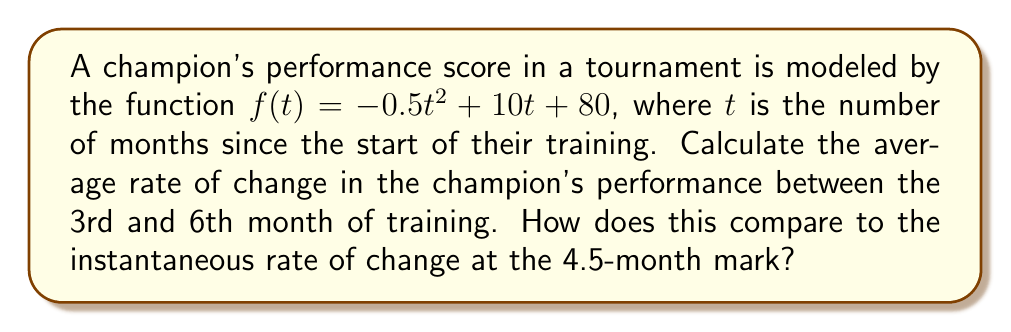Give your solution to this math problem. 1. Average rate of change:
   The average rate of change between two points is given by the slope formula:
   $$\text{Average rate of change} = \frac{f(b) - f(a)}{b - a}$$

   Let's calculate $f(3)$ and $f(6)$:
   $f(3) = -0.5(3)^2 + 10(3) + 80 = -4.5 + 30 + 80 = 105.5$
   $f(6) = -0.5(6)^2 + 10(6) + 80 = -18 + 60 + 80 = 122$

   Now, we can calculate the average rate of change:
   $$\frac{f(6) - f(3)}{6 - 3} = \frac{122 - 105.5}{3} = \frac{16.5}{3} = 5.5$$

2. Instantaneous rate of change:
   The instantaneous rate of change is given by the derivative of the function at a specific point:
   $$f'(t) = -t + 10$$

   At $t = 4.5$:
   $$f'(4.5) = -4.5 + 10 = 5.5$$

3. Comparison:
   The average rate of change between months 3 and 6 is equal to the instantaneous rate of change at the 4.5-month mark. Both are 5.5 points per month.

This equality occurs because the function is quadratic, and the average rate of change over an interval is equal to the instantaneous rate of change at the midpoint of that interval for quadratic functions.
Answer: 5.5 points/month; equal 